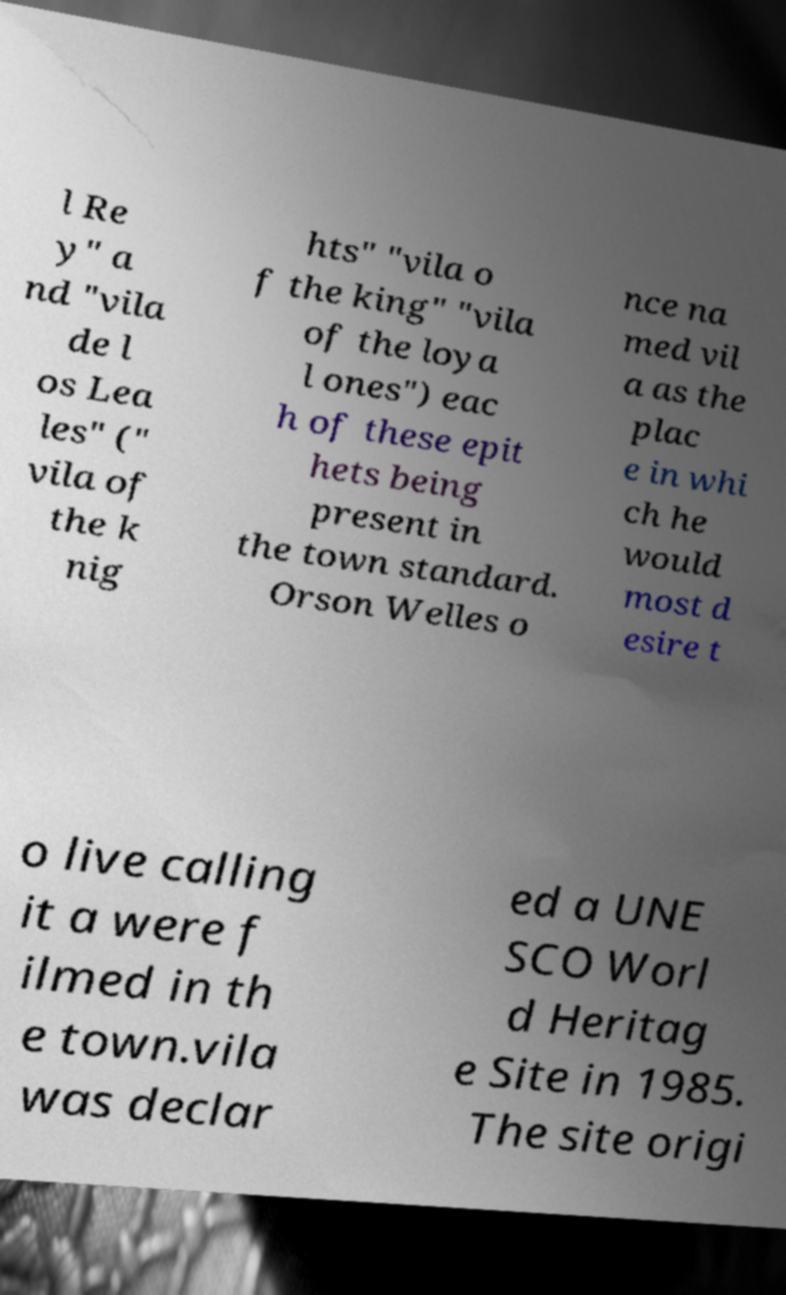What messages or text are displayed in this image? I need them in a readable, typed format. l Re y" a nd "vila de l os Lea les" (" vila of the k nig hts" "vila o f the king" "vila of the loya l ones") eac h of these epit hets being present in the town standard. Orson Welles o nce na med vil a as the plac e in whi ch he would most d esire t o live calling it a were f ilmed in th e town.vila was declar ed a UNE SCO Worl d Heritag e Site in 1985. The site origi 